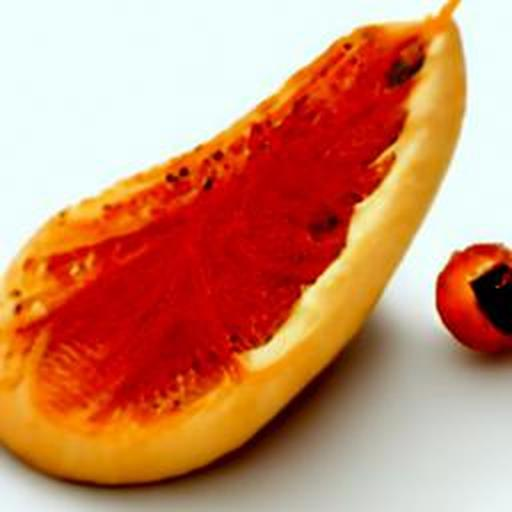What kind of fruit is shown in this image? The image depicts a slice of papaya, recognizable by its vibrant orange flesh and the unique, black, round seeds spilling out from the central cavity. 